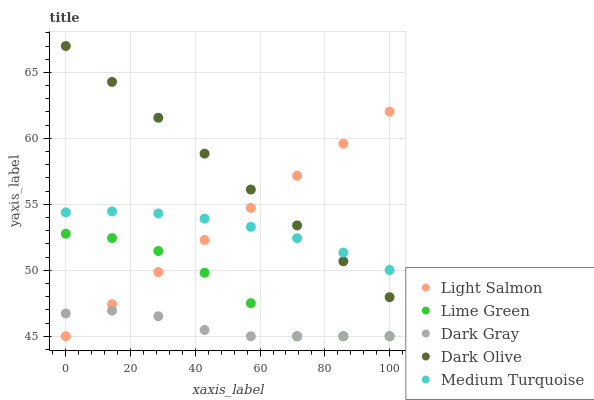Does Dark Gray have the minimum area under the curve?
Answer yes or no. Yes. Does Dark Olive have the maximum area under the curve?
Answer yes or no. Yes. Does Light Salmon have the minimum area under the curve?
Answer yes or no. No. Does Light Salmon have the maximum area under the curve?
Answer yes or no. No. Is Light Salmon the smoothest?
Answer yes or no. Yes. Is Lime Green the roughest?
Answer yes or no. Yes. Is Dark Olive the smoothest?
Answer yes or no. No. Is Dark Olive the roughest?
Answer yes or no. No. Does Dark Gray have the lowest value?
Answer yes or no. Yes. Does Dark Olive have the lowest value?
Answer yes or no. No. Does Dark Olive have the highest value?
Answer yes or no. Yes. Does Light Salmon have the highest value?
Answer yes or no. No. Is Lime Green less than Medium Turquoise?
Answer yes or no. Yes. Is Medium Turquoise greater than Dark Gray?
Answer yes or no. Yes. Does Lime Green intersect Dark Gray?
Answer yes or no. Yes. Is Lime Green less than Dark Gray?
Answer yes or no. No. Is Lime Green greater than Dark Gray?
Answer yes or no. No. Does Lime Green intersect Medium Turquoise?
Answer yes or no. No. 